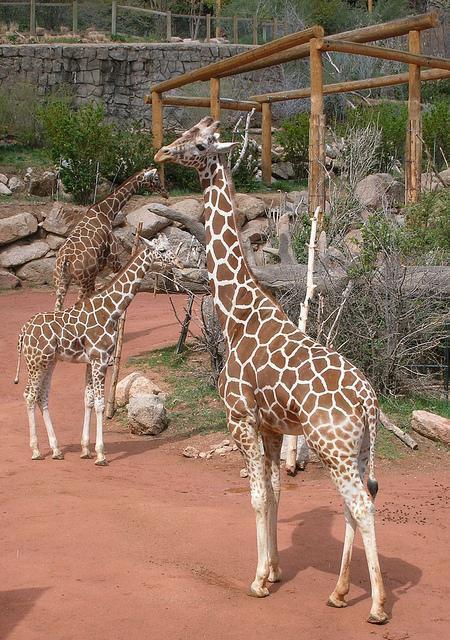How many animals?
Give a very brief answer. 3. How many posts?
Give a very brief answer. 5. How many giraffes are in the photo?
Give a very brief answer. 3. How many spoons are on the table?
Give a very brief answer. 0. 